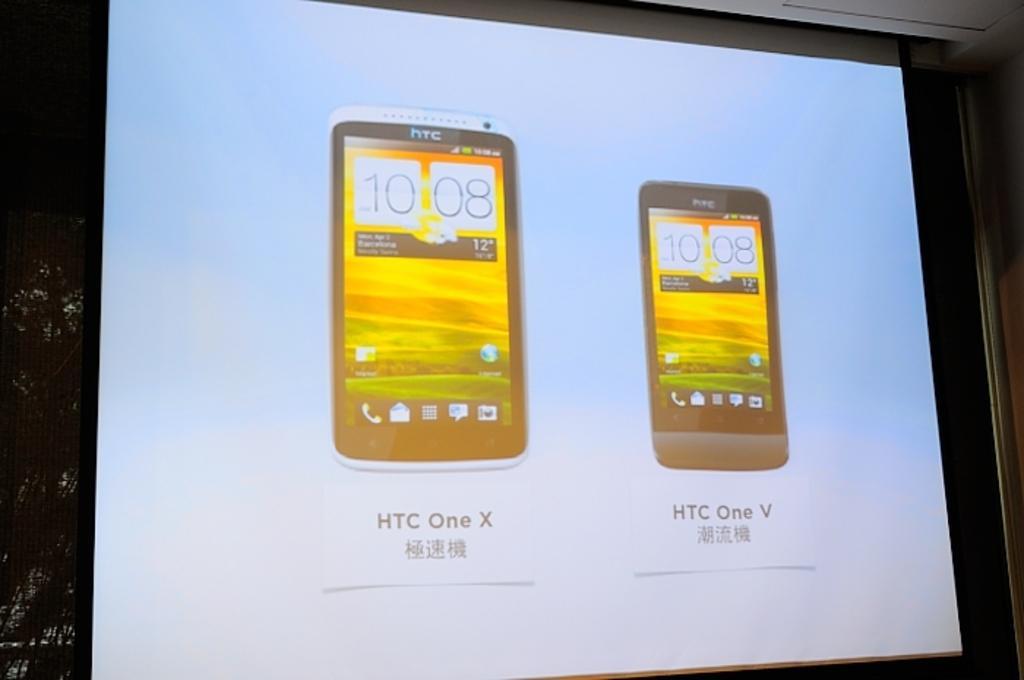Could you give a brief overview of what you see in this image? In the image we can see projected screen, on the projected screen we can see the pictures of mobile phone and the background is dark. 